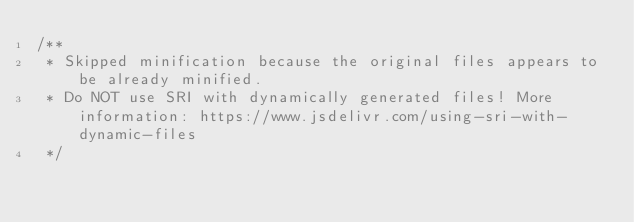Convert code to text. <code><loc_0><loc_0><loc_500><loc_500><_JavaScript_>/**
 * Skipped minification because the original files appears to be already minified.
 * Do NOT use SRI with dynamically generated files! More information: https://www.jsdelivr.com/using-sri-with-dynamic-files
 */</code> 